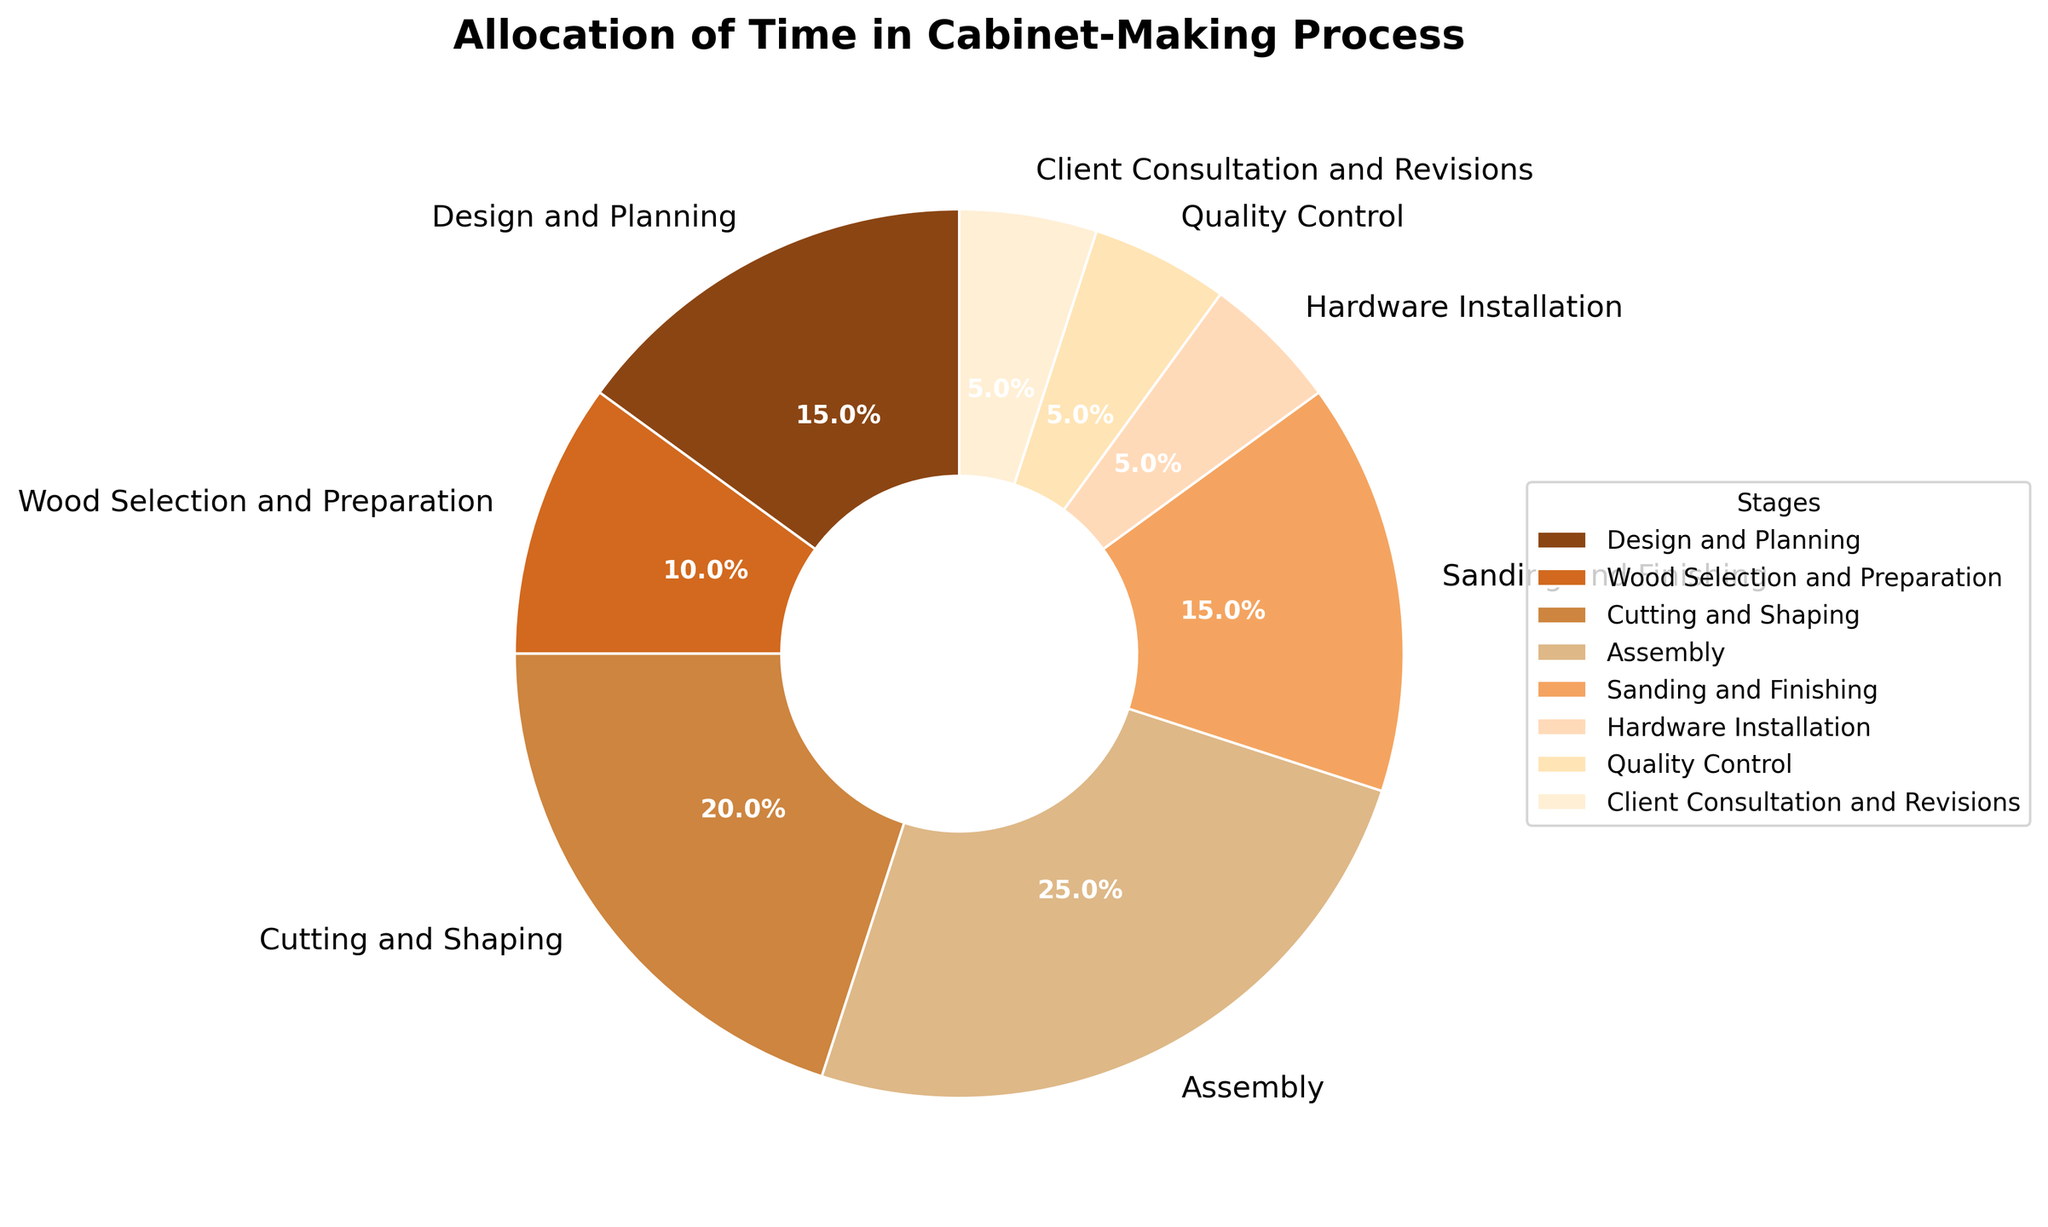What's the total percentage of time spent on Design and Planning and Assembly? To find the total percentage of time spent on Design and Planning and Assembly, sum their percentages: 15% (Design and Planning) + 25% (Assembly) = 40%.
Answer: 40% Which stage takes up more time, Sanding and Finishing or Cutting and Shaping? Compare the percentages of Sanding and Finishing (15%) and Cutting and Shaping (20%). Since 20% is greater than 15%, Cutting and Shaping takes up more time.
Answer: Cutting and Shaping What percentage of time is spent on stages related to preparation (Design and Planning, Wood Selection and Preparation, Cutting and Shaping)? Sum the percentages of Design and Planning (15%), Wood Selection and Preparation (10%), and Cutting and Shaping (20%): 15 + 10 + 20 = 45%.
Answer: 45% Which stage has the smallest allocation of time? Look at the percentages and find the smallest one. The smallest percentage is 5%, and the stages with this allocation are Hardware Installation, Quality Control, and Client Consultation and Revisions.
Answer: Hardware Installation, Quality Control, Client Consultation and Revisions How does the time spent on Assembly compare to the time spent on Client Consultation and Revisions? Compare the percentages of Assembly (25%) and Client Consultation and Revisions (5%). Assembly time is 5 times greater than Client Consultation and Revisions time.
Answer: Assembly is 5 times greater What’s the difference in the time allocation between the stage with the largest percentage and the stage with the smallest percentage? The stage with the largest percentage is Assembly (25%), and the stages with the smallest percentage are Hardware Installation, Quality Control, and Client Consultation and Revisions (each 5%). The difference is 25% - 5% = 20%.
Answer: 20% Is the total time spent on Sanding and Finishing and Hardware Installation more or less than the time spent on Assembly? Sum the percentages for Sanding and Finishing (15%) and Hardware Installation (5%): 15 + 5 = 20%. Compare that to Assembly's 25%. Since 20% is less than 25%, it is less.
Answer: Less What is the combined time spent on the quality assurance stages (Quality Control and Client Consultation and Revisions)? Sum the percentages for Quality Control (5%) and Client Consultation and Revisions (5%): 5 + 5 = 10%.
Answer: 10% How much more time is spent on Sanding and Finishing compared to Hardware Installation? Subtract the percentage of Hardware Installation (5%) from Sanding and Finishing (15%): 15% - 5% = 10%.
Answer: 10% 